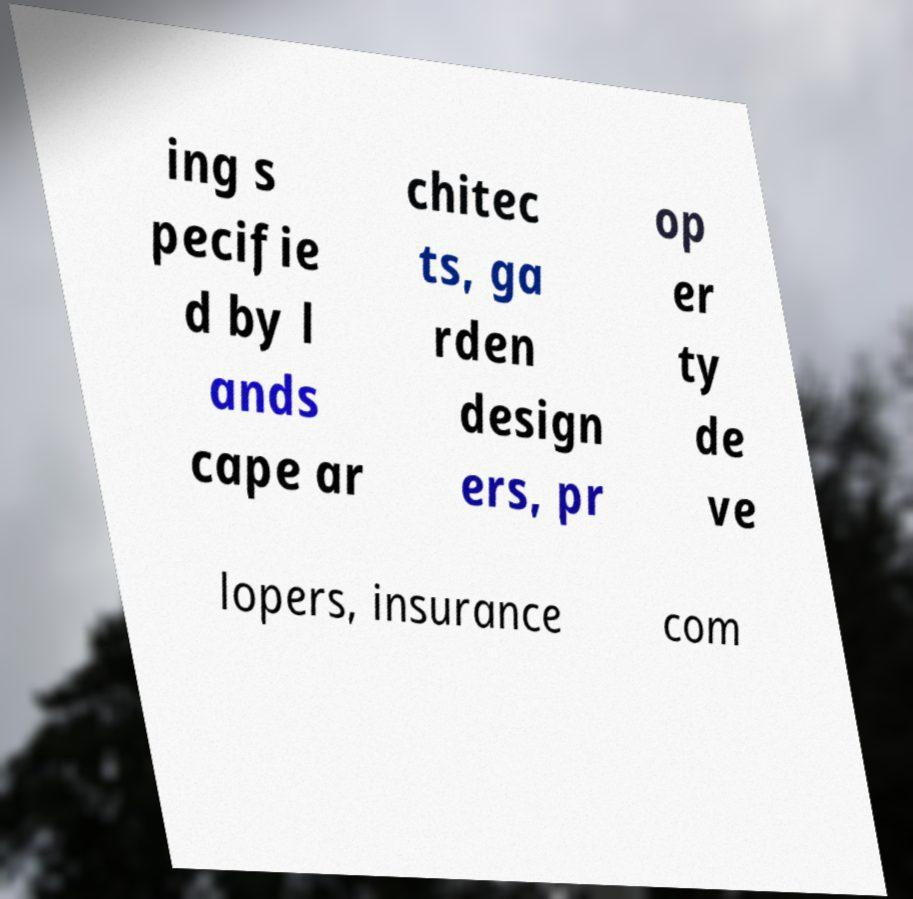Can you accurately transcribe the text from the provided image for me? ing s pecifie d by l ands cape ar chitec ts, ga rden design ers, pr op er ty de ve lopers, insurance com 